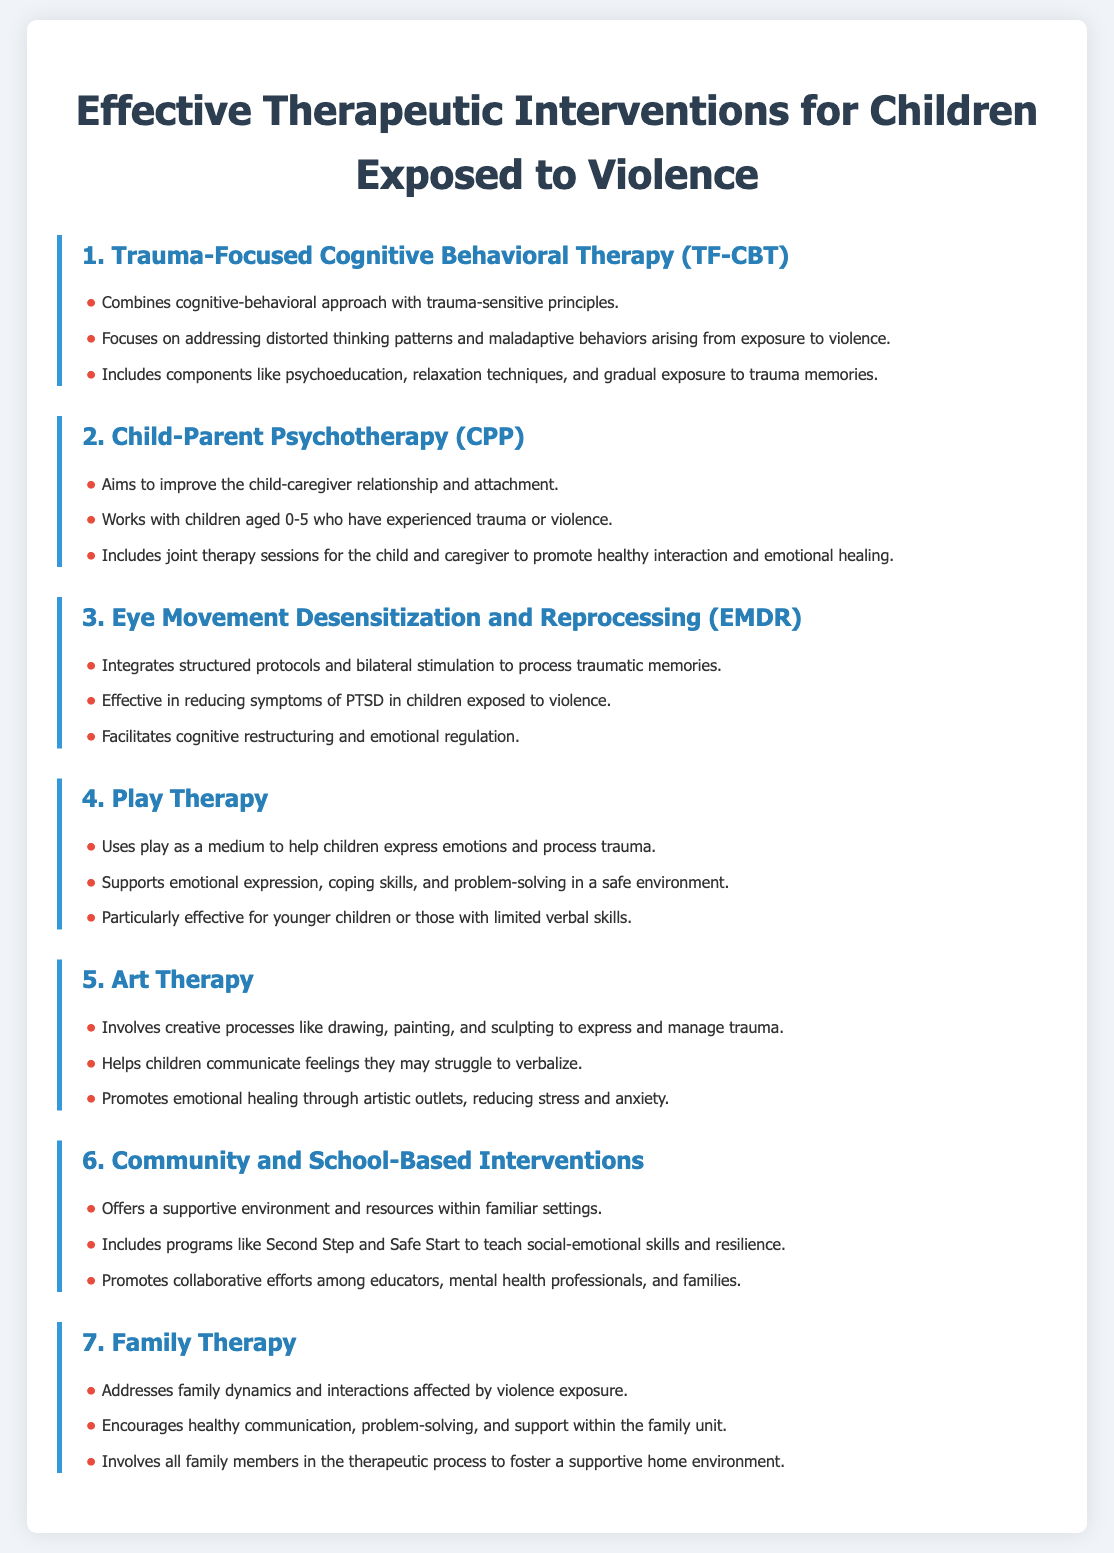What is the first intervention listed? The first intervention listed is titled "Trauma-Focused Cognitive Behavioral Therapy (TF-CBT)".
Answer: Trauma-Focused Cognitive Behavioral Therapy (TF-CBT) How many therapeutic interventions are mentioned in the document? The document includes a total of seven therapeutic interventions for children exposed to violence.
Answer: 7 What age group does Child-Parent Psychotherapy (CPP) target? Child-Parent Psychotherapy specifically works with children aged 0-5 who have experienced trauma or violence.
Answer: 0-5 What therapy integrates structured protocols and bilateral stimulation? Eye Movement Desensitization and Reprocessing (EMDR) integrates structured protocols and bilateral stimulation to process traumatic memories.
Answer: Eye Movement Desensitization and Reprocessing (EMDR) Which intervention uses play as a medium for children? Play Therapy is the intervention that utilizes play to help children express emotions and process trauma.
Answer: Play Therapy What is a key benefit of Art Therapy for children? Art Therapy helps children communicate feelings they may struggle to verbalize through creative processes like drawing and painting.
Answer: Communicate feelings Which intervention promotes collaborative efforts among educators, mental health professionals, and families? Community and School-Based Interventions promote collaborative efforts among educators, mental health professionals, and families.
Answer: Community and School-Based Interventions How does Family Therapy aim to support children? Family Therapy encourages healthy communication, problem-solving, and support within the family unit, addressing family dynamics affected by violence exposure.
Answer: Healthy communication 